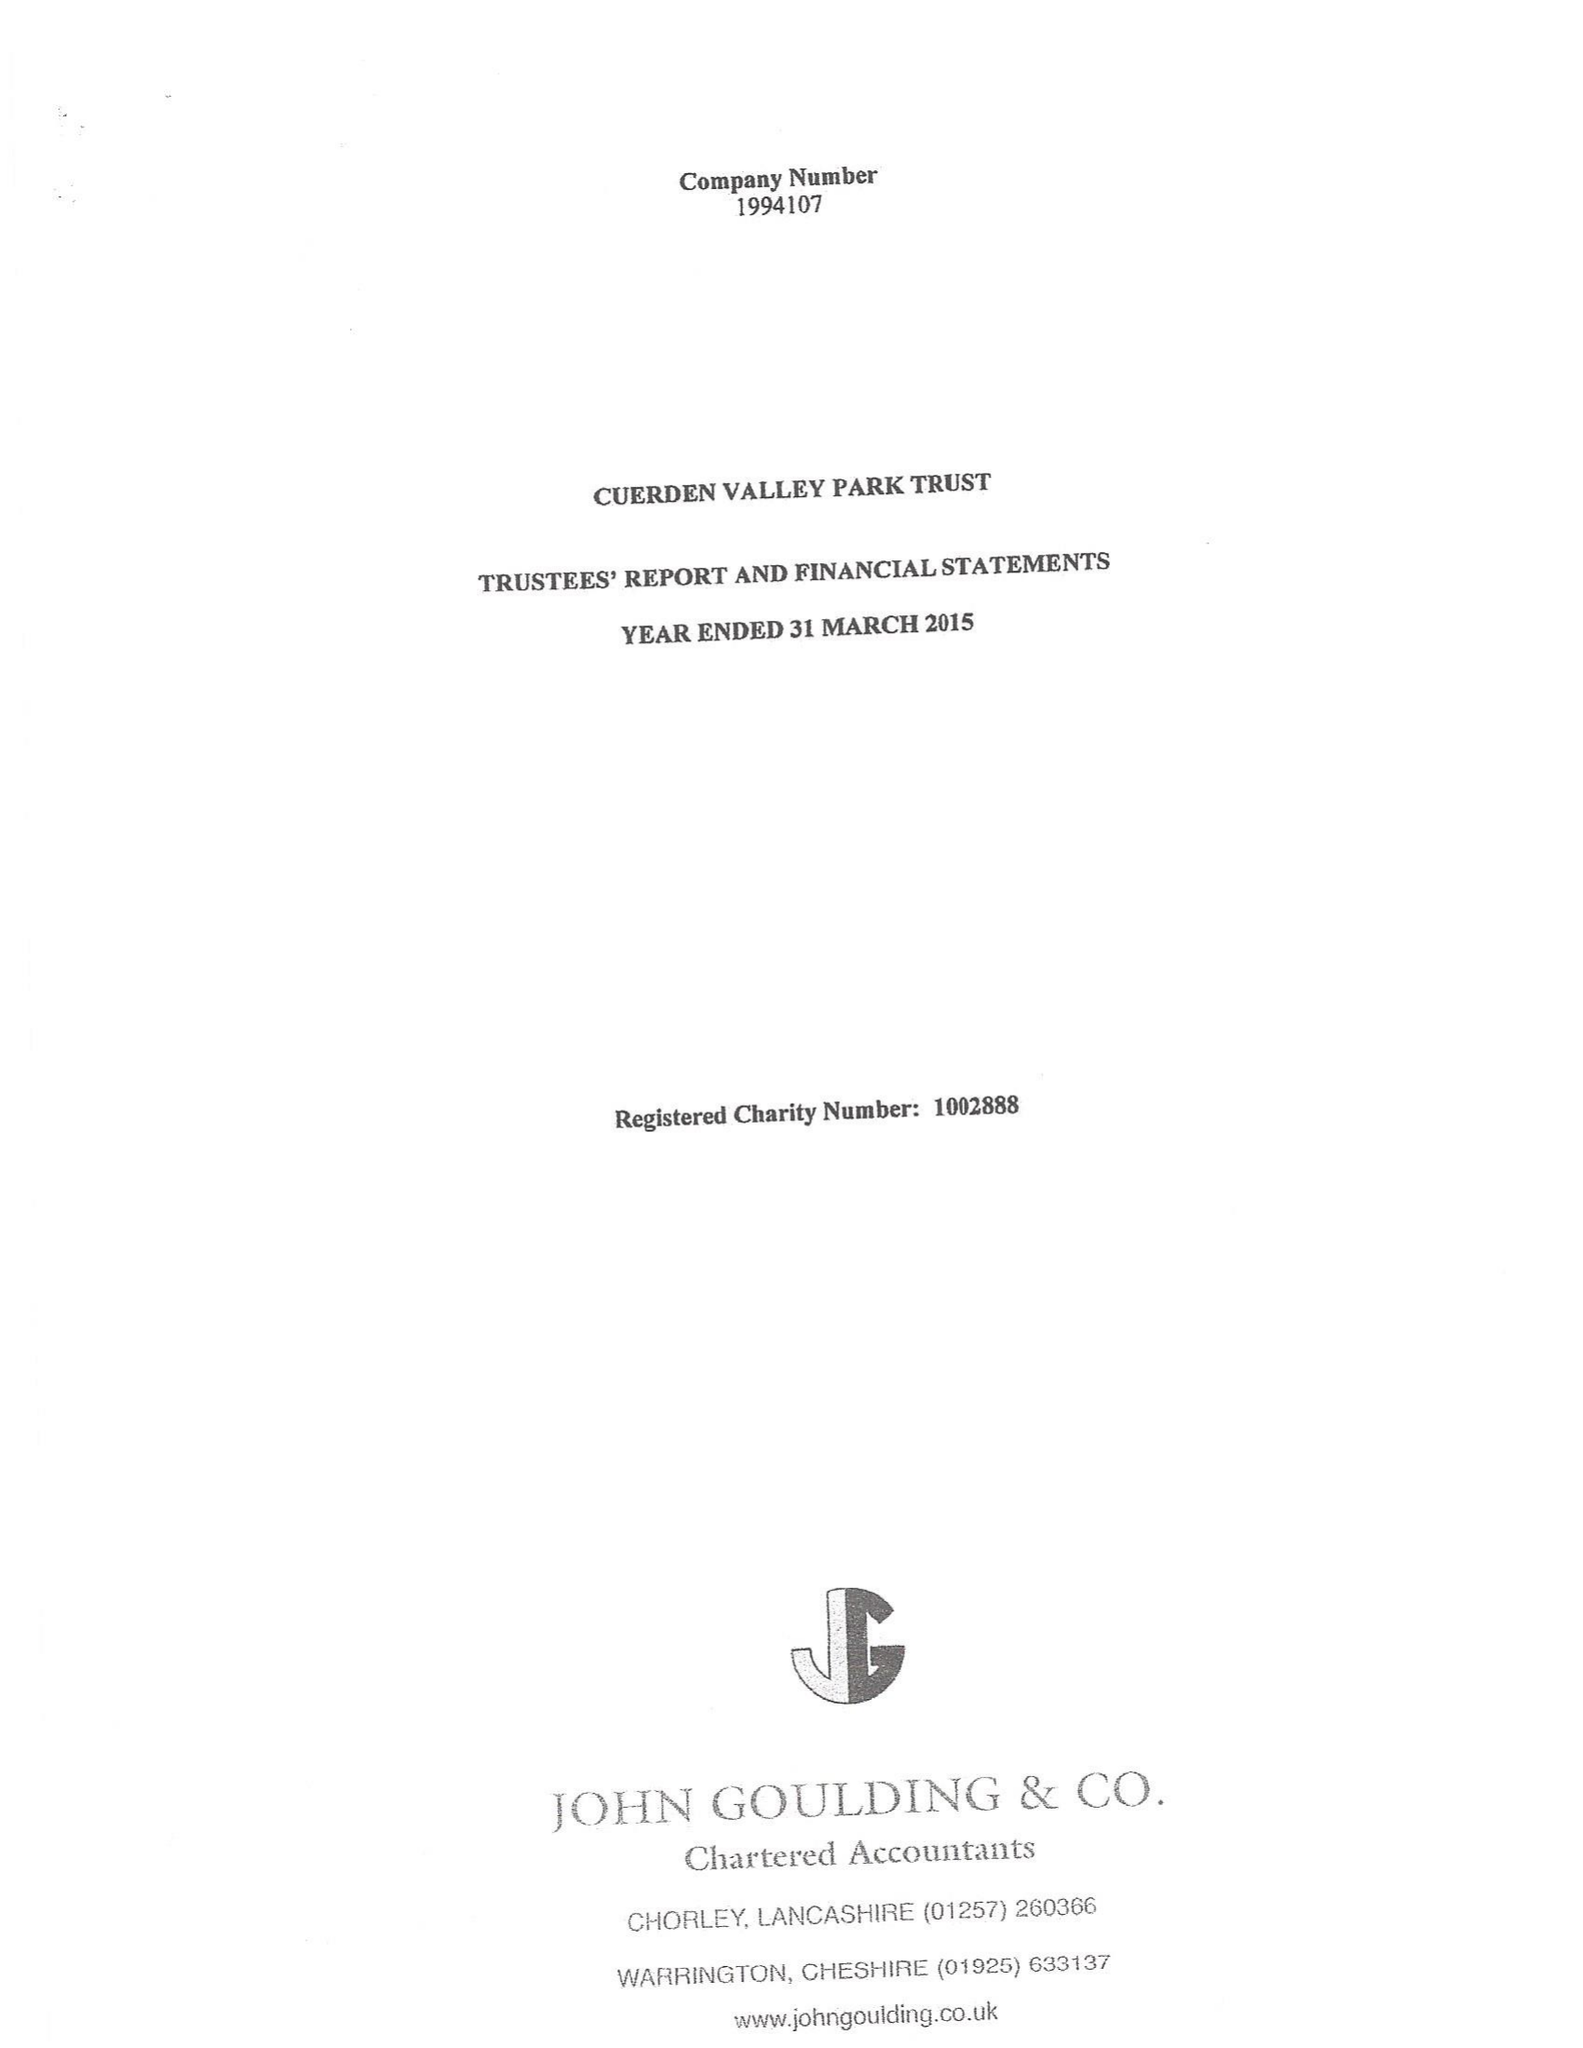What is the value for the address__street_line?
Answer the question using a single word or phrase. BERKELEY DRIVE 